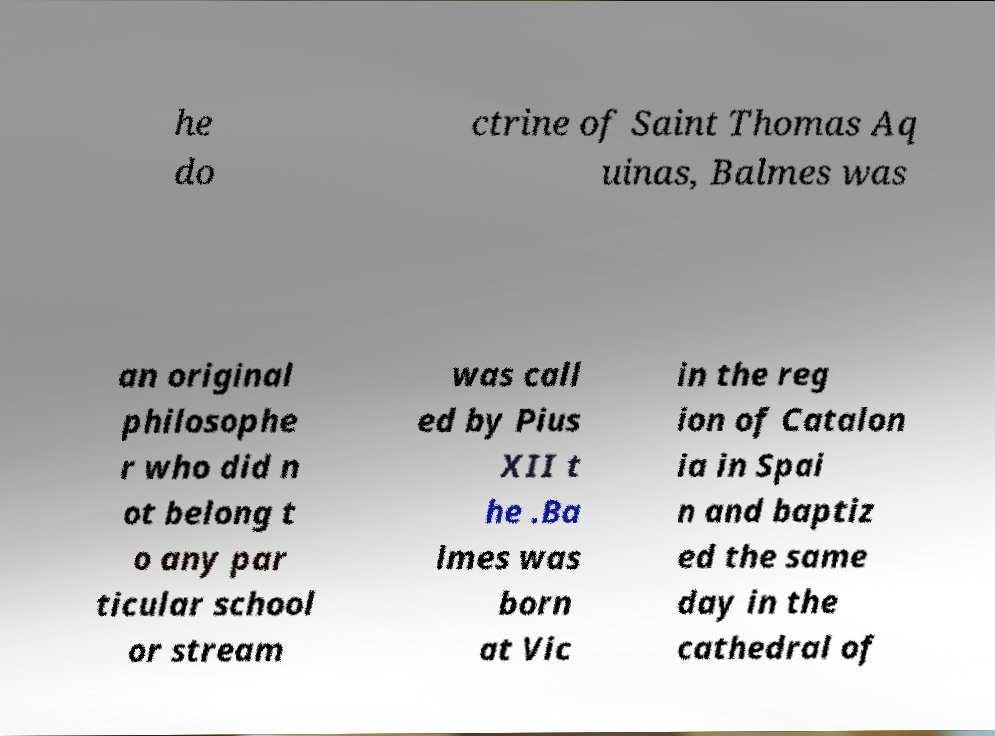For documentation purposes, I need the text within this image transcribed. Could you provide that? he do ctrine of Saint Thomas Aq uinas, Balmes was an original philosophe r who did n ot belong t o any par ticular school or stream was call ed by Pius XII t he .Ba lmes was born at Vic in the reg ion of Catalon ia in Spai n and baptiz ed the same day in the cathedral of 